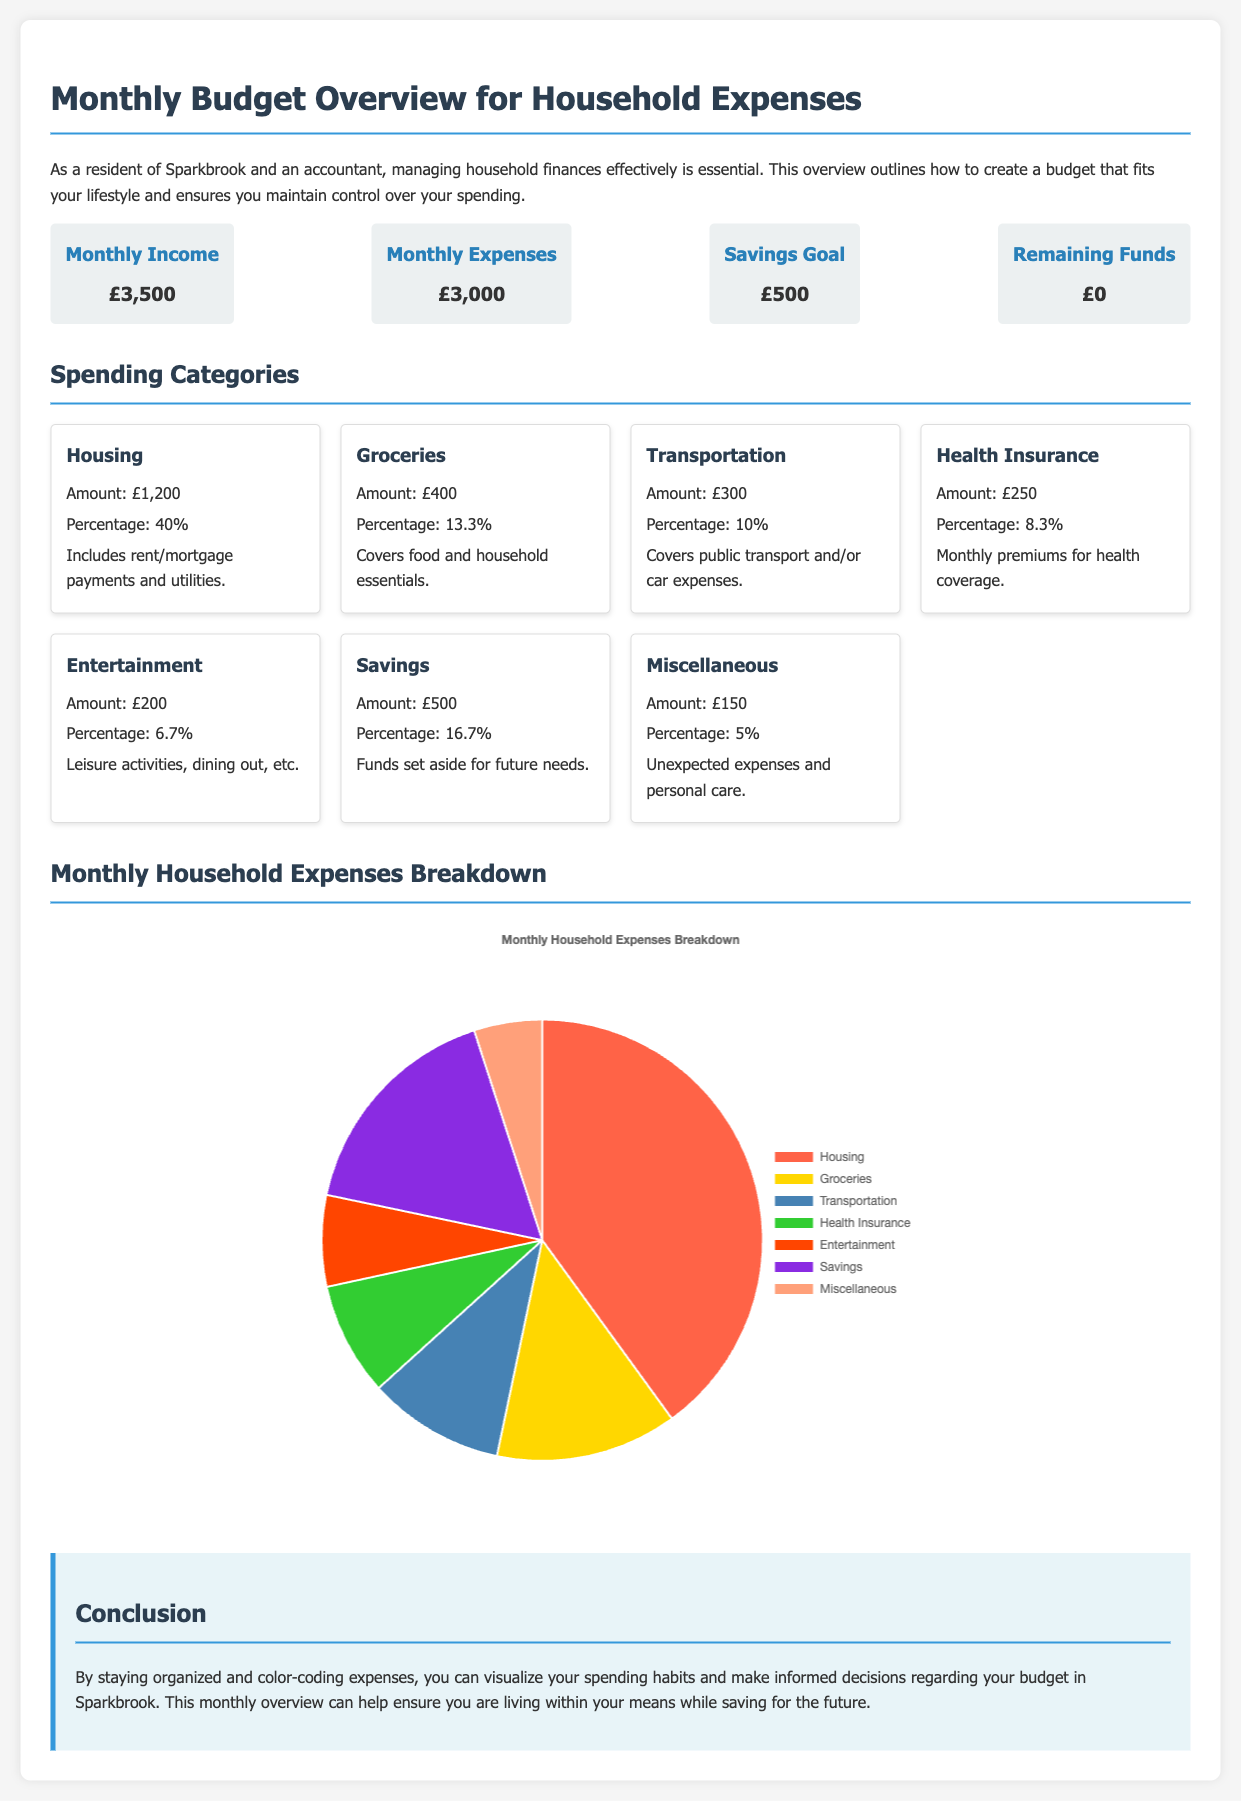What is the total monthly income? The total monthly income is clearly stated in the budget overview.
Answer: £3,500 What percentage of expenses is allocated to housing? The percentage for housing is provided in the spending categories section.
Answer: 40% How much is budgeted for groceries? The amount designated for groceries can be found in the spending categories.
Answer: £400 What is the remaining funds after expenses? The remaining funds are listed in the budget overview after considering income and expenses.
Answer: £0 What is the percentage of the budget allocated to savings? The savings percentage is explicitly mentioned under spending categories.
Answer: 16.7% Which category has the least amount of spending? The category with the least spending is specified in the spending categories section.
Answer: Miscellaneous What color represents transportation in the pie chart? The colors corresponding to each category in the pie chart can be deduced from the chart description.
Answer: Steel Blue How much is planned for entertainment expenses? The entertainment budget is detailed in the spending categories.
Answer: £200 What is the average percentage of the expenses across all categories listed? The average would require a calculation based on the percentages listed in the spending categories.
Answer: 13.5% 